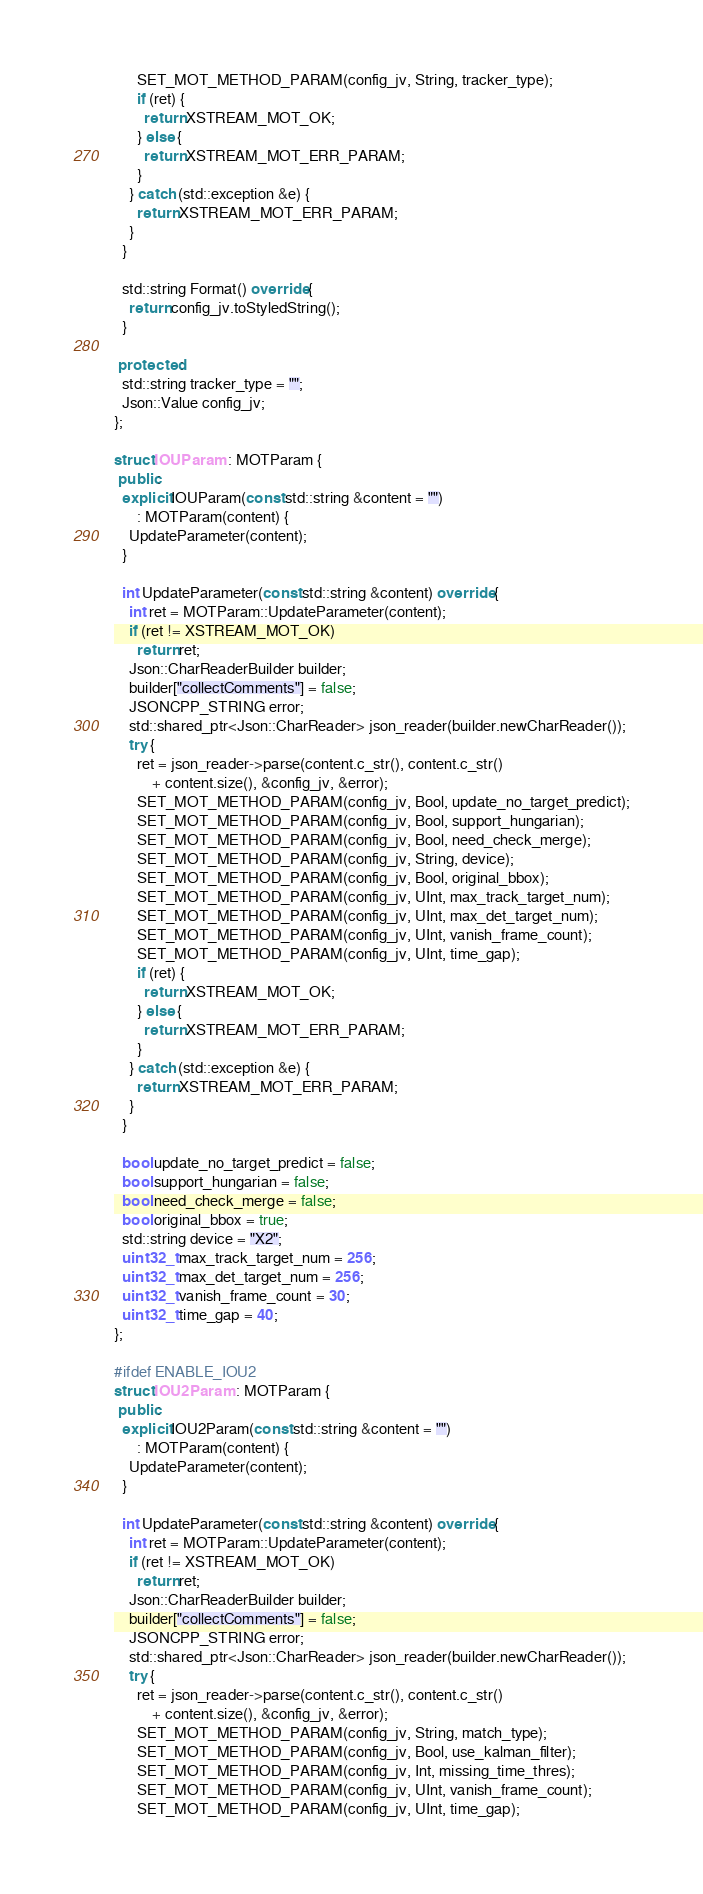<code> <loc_0><loc_0><loc_500><loc_500><_C++_>      SET_MOT_METHOD_PARAM(config_jv, String, tracker_type);
      if (ret) {
        return XSTREAM_MOT_OK;
      } else {
        return XSTREAM_MOT_ERR_PARAM;
      }
    } catch (std::exception &e) {
      return XSTREAM_MOT_ERR_PARAM;
    }
  }

  std::string Format() override {
    return config_jv.toStyledString();
  }

 protected:
  std::string tracker_type = "";
  Json::Value config_jv;
};

struct IOUParam : MOTParam {
 public:
  explicit IOUParam(const std::string &content = "")
      : MOTParam(content) {
    UpdateParameter(content);
  }

  int UpdateParameter(const std::string &content) override {
    int ret = MOTParam::UpdateParameter(content);
    if (ret != XSTREAM_MOT_OK)
      return ret;
    Json::CharReaderBuilder builder;
    builder["collectComments"] = false;
    JSONCPP_STRING error;
    std::shared_ptr<Json::CharReader> json_reader(builder.newCharReader());
    try {
      ret = json_reader->parse(content.c_str(), content.c_str()
          + content.size(), &config_jv, &error);
      SET_MOT_METHOD_PARAM(config_jv, Bool, update_no_target_predict);
      SET_MOT_METHOD_PARAM(config_jv, Bool, support_hungarian);
      SET_MOT_METHOD_PARAM(config_jv, Bool, need_check_merge);
      SET_MOT_METHOD_PARAM(config_jv, String, device);
      SET_MOT_METHOD_PARAM(config_jv, Bool, original_bbox);
      SET_MOT_METHOD_PARAM(config_jv, UInt, max_track_target_num);
      SET_MOT_METHOD_PARAM(config_jv, UInt, max_det_target_num);
      SET_MOT_METHOD_PARAM(config_jv, UInt, vanish_frame_count);
      SET_MOT_METHOD_PARAM(config_jv, UInt, time_gap);
      if (ret) {
        return XSTREAM_MOT_OK;
      } else {
        return XSTREAM_MOT_ERR_PARAM;
      }
    } catch (std::exception &e) {
      return XSTREAM_MOT_ERR_PARAM;
    }
  }

  bool update_no_target_predict = false;
  bool support_hungarian = false;
  bool need_check_merge = false;
  bool original_bbox = true;
  std::string device = "X2";
  uint32_t max_track_target_num = 256;
  uint32_t max_det_target_num = 256;
  uint32_t vanish_frame_count = 30;
  uint32_t time_gap = 40;
};

#ifdef ENABLE_IOU2
struct IOU2Param : MOTParam {
 public:
  explicit IOU2Param(const std::string &content = "")
      : MOTParam(content) {
    UpdateParameter(content);
  }

  int UpdateParameter(const std::string &content) override {
    int ret = MOTParam::UpdateParameter(content);
    if (ret != XSTREAM_MOT_OK)
      return ret;
    Json::CharReaderBuilder builder;
    builder["collectComments"] = false;
    JSONCPP_STRING error;
    std::shared_ptr<Json::CharReader> json_reader(builder.newCharReader());
    try {
      ret = json_reader->parse(content.c_str(), content.c_str()
          + content.size(), &config_jv, &error);
      SET_MOT_METHOD_PARAM(config_jv, String, match_type);
      SET_MOT_METHOD_PARAM(config_jv, Bool, use_kalman_filter);
      SET_MOT_METHOD_PARAM(config_jv, Int, missing_time_thres);
      SET_MOT_METHOD_PARAM(config_jv, UInt, vanish_frame_count);
      SET_MOT_METHOD_PARAM(config_jv, UInt, time_gap);</code> 